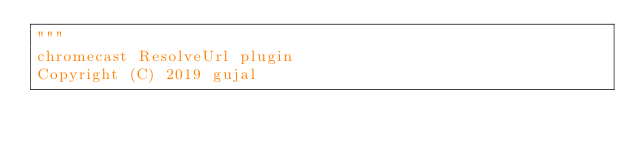<code> <loc_0><loc_0><loc_500><loc_500><_Python_>"""
chromecast ResolveUrl plugin
Copyright (C) 2019 gujal
</code> 